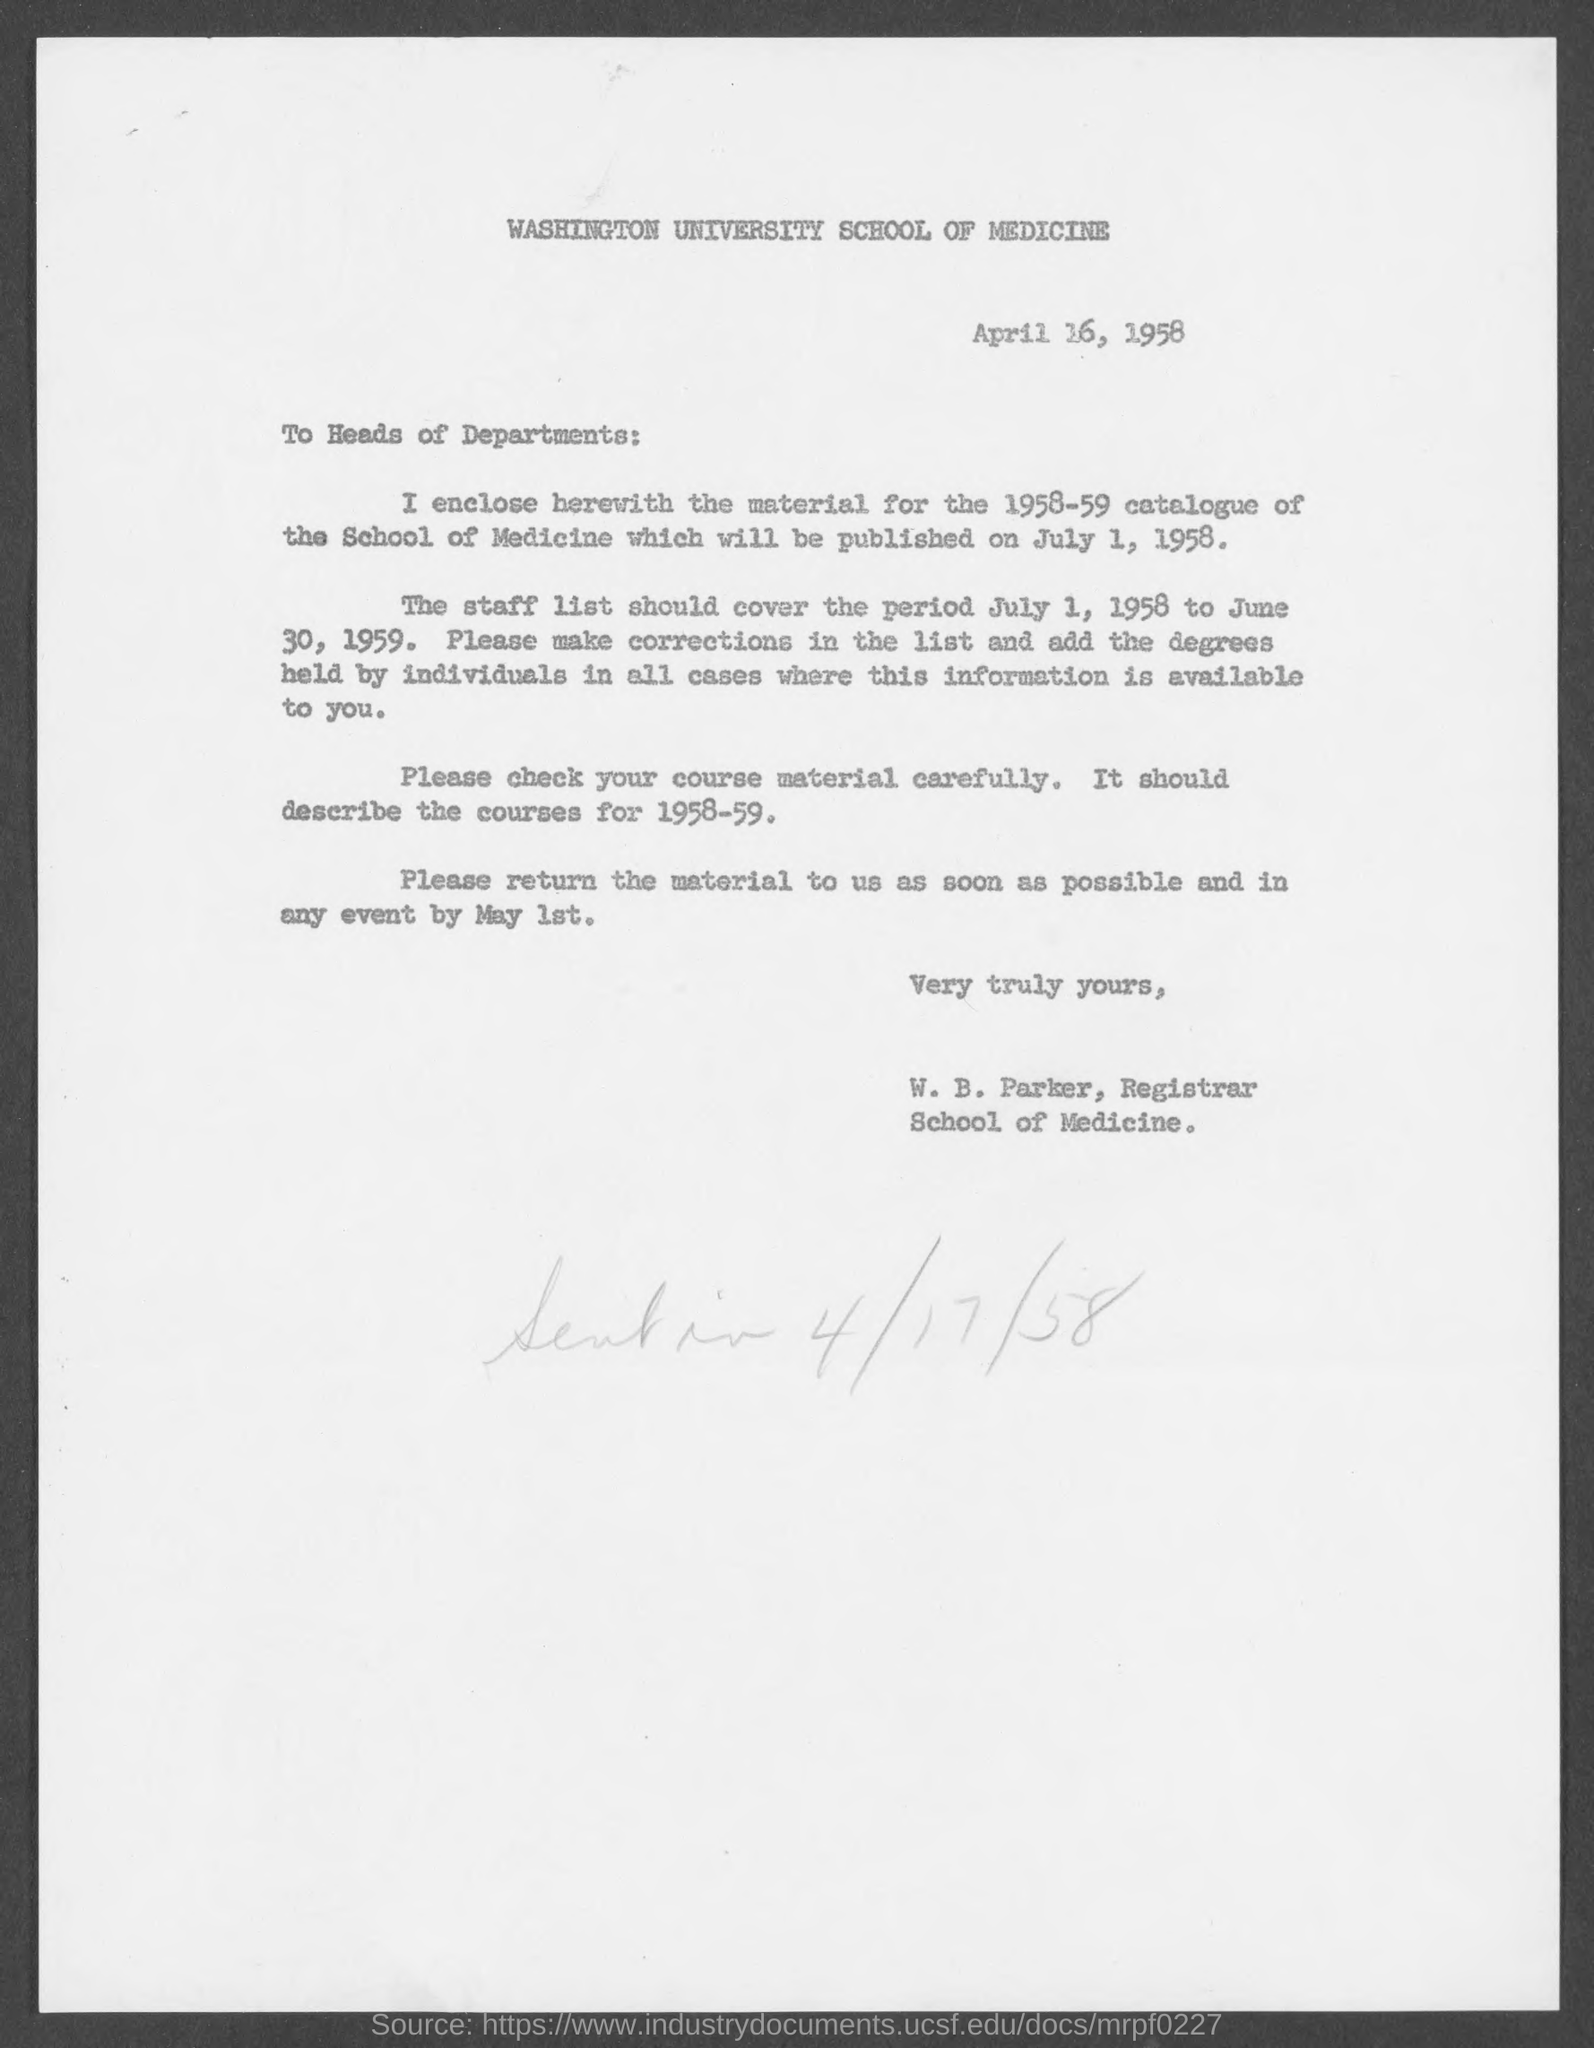What is the salutation of this letter?
Ensure brevity in your answer.  To Heads of Departments:. 